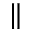<formula> <loc_0><loc_0><loc_500><loc_500>\|</formula> 